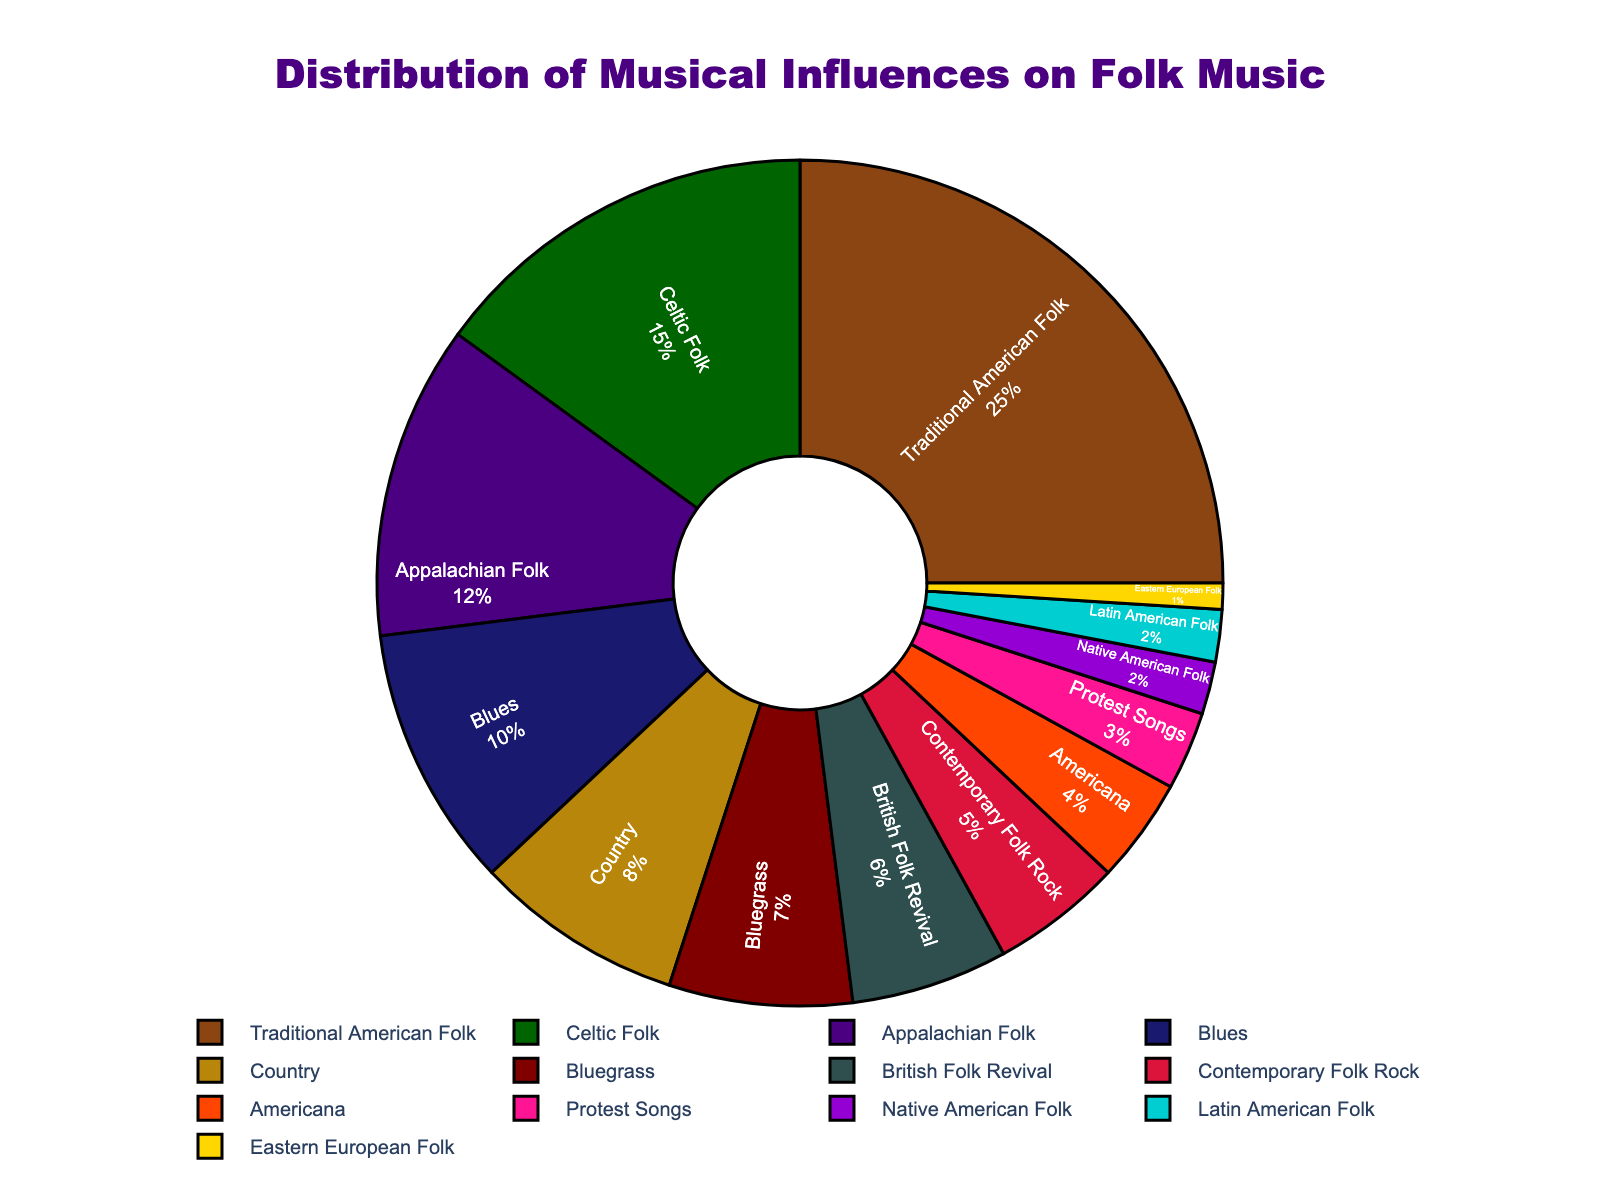What percentage of the musical influences comes from Traditional American Folk? By observing the pie chart, you can see that the slice representing Traditional American Folk shows a percentage label.
Answer: 25% What is the combined percentage of influences from Blues and Country? To find the combined percentage, add the individual percentages of Blues (10%) and Country (8%). So, 10% + 8% = 18%.
Answer: 18% Which genre contributes more to the folk music influences: British Folk Revival or Contemporary Folk Rock? Compare the percentages shown on the pie chart for British Folk Revival (6%) and Contemporary Folk Rock (5%). Since 6% is greater than 5%, British Folk Revival contributes more.
Answer: British Folk Revival What is the total percentage of influences from genres with less than 5% contribution each (i.e., Protest Songs, Native American Folk, Latin American Folk, Eastern European Folk)? Summing the percentages of Protest Songs (3%), Native American Folk (2%), Latin American Folk (2%), and Eastern European Folk (1%): 3% + 2% + 2% + 1% = 8%.
Answer: 8% Which genres are represented by the green and blue slices in the pie chart? By referring to the label colors in the pie chart, the green slice represents Celtic Folk, and the blue slice represents Blues.
Answer: Celtic Folk, Blues What genre has the smallest influence on folk music, and what is its percentage? The smallest slice in the pie chart represents Eastern European Folk, with a percentage shown on the label.
Answer: Eastern European Folk, 1% How does the influence of Appalachian Folk compare to that of Bluegrass? By observing the pie chart, compare the percentages for Appalachian Folk (12%) and Bluegrass (7%). Since 12% is greater than 7%, Appalachian Folk has a higher influence.
Answer: Appalachian Folk What is the combined percentage of the two largest influences on folk music? The two largest influences are Traditional American Folk (25%) and Celtic Folk (15%). Adding these together, we get 25% + 15% = 40%.
Answer: 40% If we combine the percentages of Country and Americana, how does their total compare to the influence of Blues? Sum the percentages of Country (8%) and Americana (4%): 8% + 4% = 12%. Compare this to Blues (10%). Since 12% is greater than 10%, the combined percentage of Country and Americana is higher than Blues.
Answer: Higher 